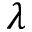Convert formula to latex. <formula><loc_0><loc_0><loc_500><loc_500>\lambda</formula> 